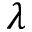Convert formula to latex. <formula><loc_0><loc_0><loc_500><loc_500>\lambda</formula> 